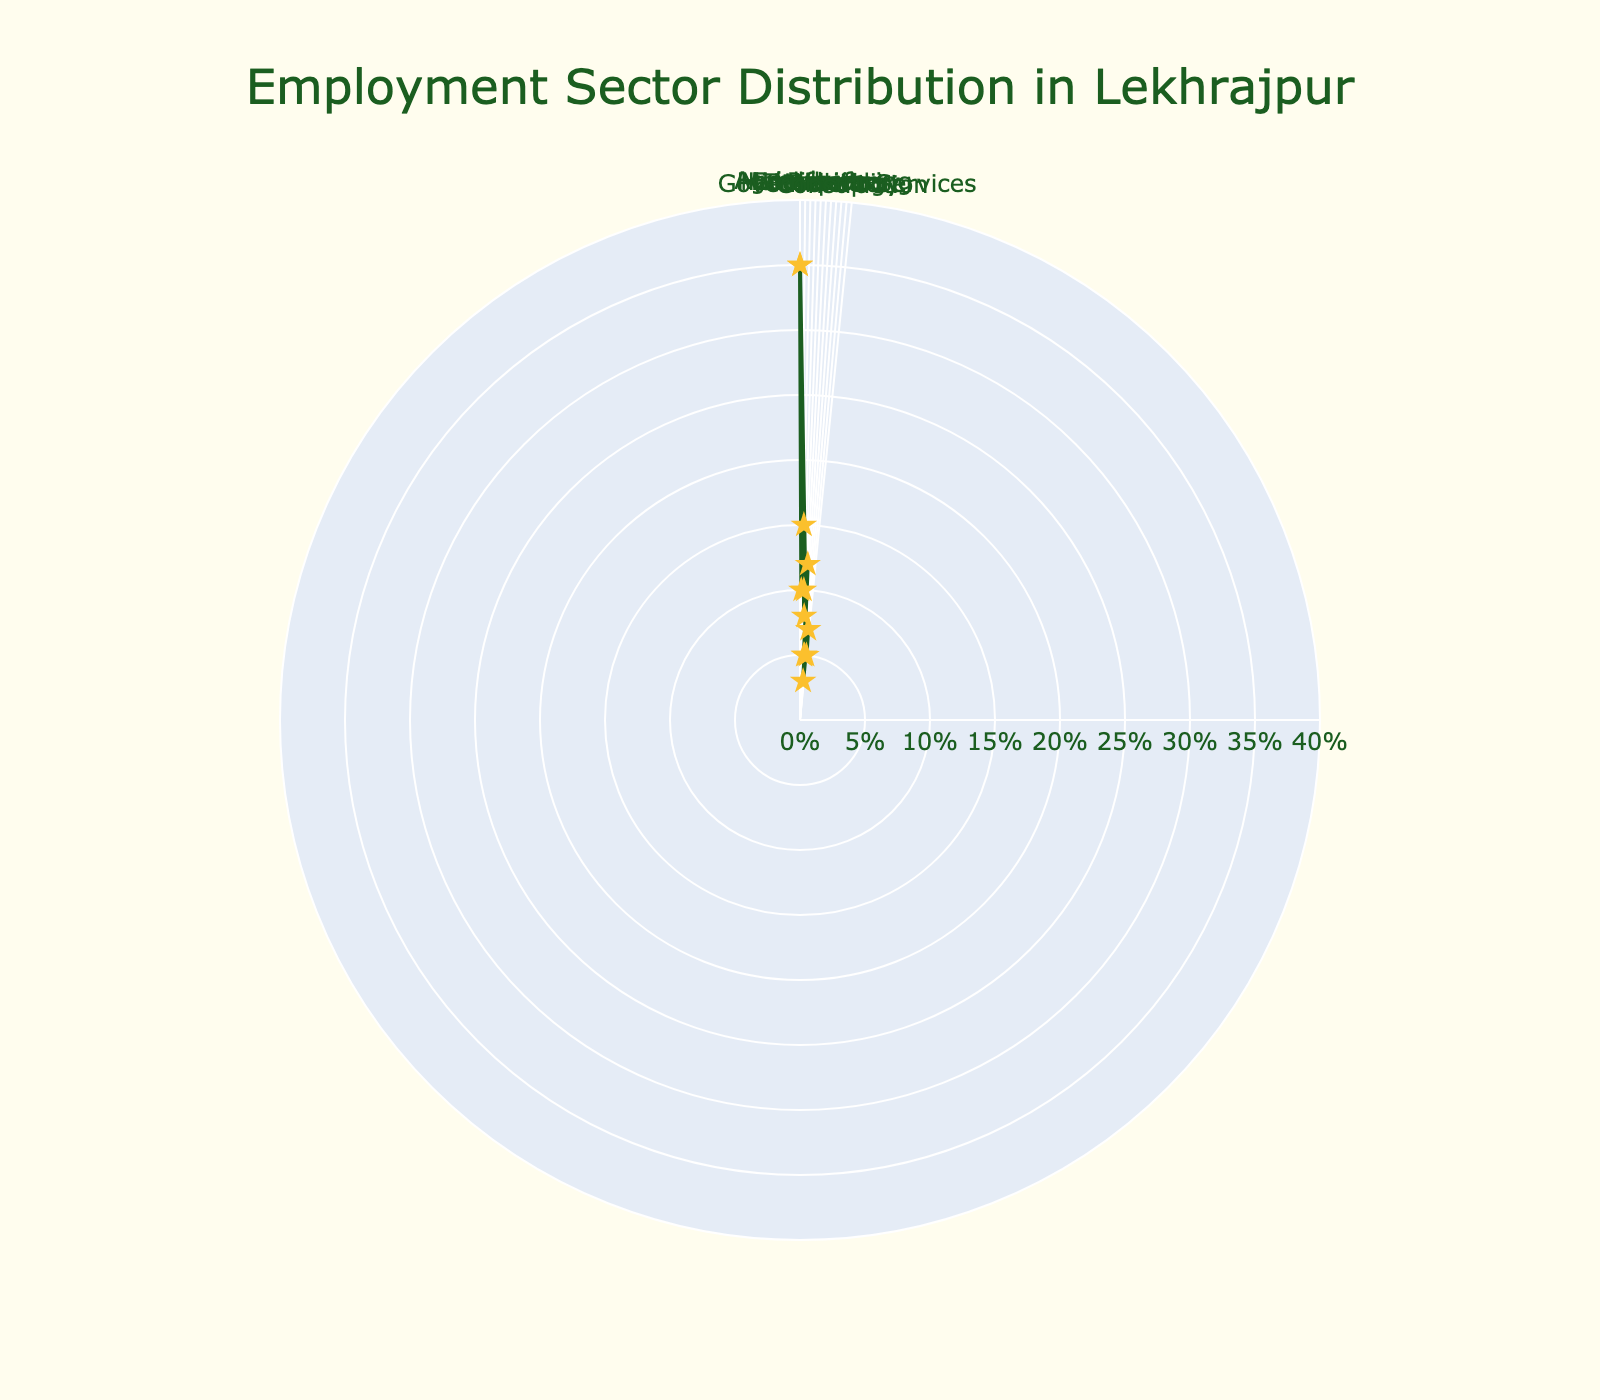How many employment sectors are represented in the rose chart? Count the number of unique sectors displayed in the figure. From the data table, there are 11 sectors: Agriculture, Handicrafts, Education, Healthcare, Retail, Manufacturing, Technology, Hospitality, Transport, Government Services, and Construction.
Answer: 11 What percentage of Lekhrajpur residents work in the Agriculture sector? Identify the portion of the rose chart representing the Agriculture sector and read off the indicated percentage. The Agriculture sector is labeled with 35%.
Answer: 35% Which employment sector has the least representation among Lekhrajpur residents? Scan through the percentages in the rose chart and identify the sector with the smallest value. The Transport sector has the least representation at 3%.
Answer: Transport How does the percentage of residents working in Education compare to those in Healthcare? Compare the percentages of the Education and Healthcare sectors. Both Education and Healthcare sectors have the same representation of 10%.
Answer: Equal What is the total percentage of Lekhrajpur residents working in Retail, Manufacturing, and Technology combined? Sum the percentages of Retail (8%), Manufacturing (12%), and Technology (5%). The combined total is 8 + 12 + 5 = 25%.
Answer: 25% Which sectors have an equal percentage of employment distribution? Look for sectors with identical percentages. Healthcare, Handicrafts, and Hospitality sectors all have 10% representation each.
Answer: Healthcare, Handicrafts, Hospitality Is the percentage of residents in Government Services greater than those in Construction? Compare the percentages; Government Services has 7% whereas Construction has 5%, so it is greater.
Answer: Yes What is the average percentage of residents working in Handicrafts, Healthcare, and Government Services? Calculate the average of the three percentages: (10 + 10 + 7) / 3. The sum is 27, so the average is 27 / 3 = 9%.
Answer: 9% Which two sectors are tied at 5% each in employment distribution? Identify the sectors that both have 5% representation from the data. They are Technology, Hospitality, and Construction.
Answer: Technology, Hospitality 